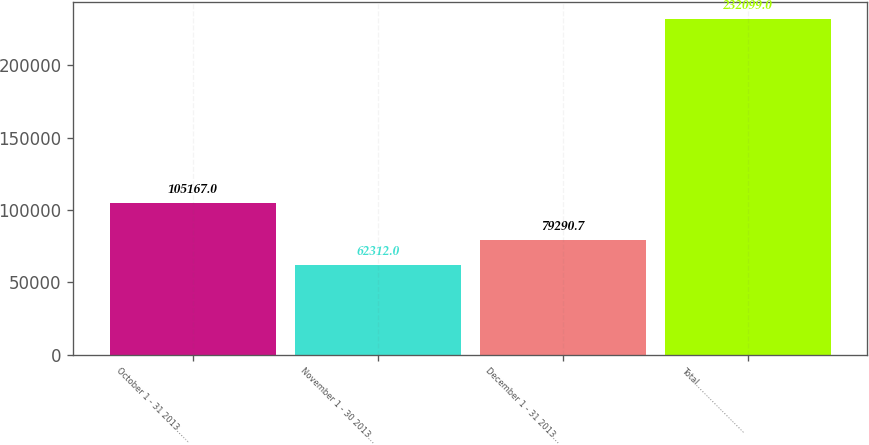Convert chart to OTSL. <chart><loc_0><loc_0><loc_500><loc_500><bar_chart><fcel>October 1 - 31 2013……<fcel>November 1 - 30 2013…<fcel>December 1 - 31 2013…<fcel>Total……………………<nl><fcel>105167<fcel>62312<fcel>79290.7<fcel>232099<nl></chart> 